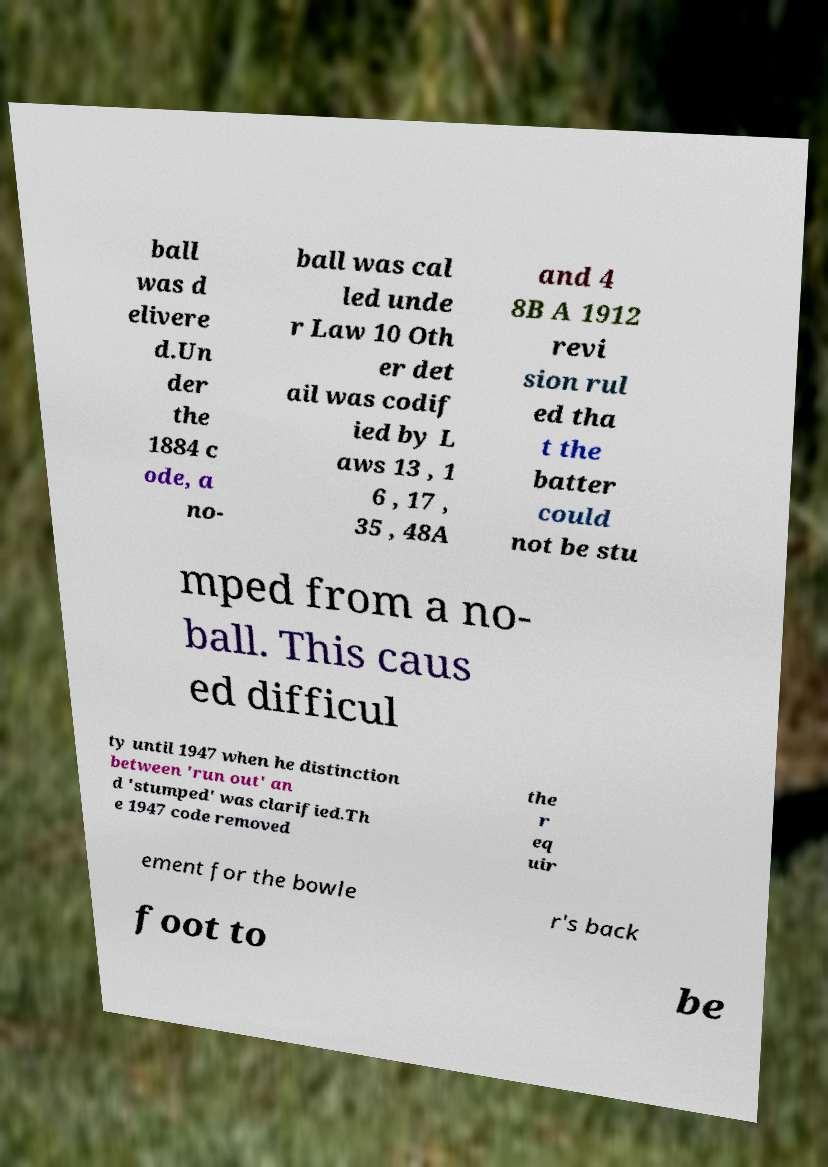For documentation purposes, I need the text within this image transcribed. Could you provide that? ball was d elivere d.Un der the 1884 c ode, a no- ball was cal led unde r Law 10 Oth er det ail was codif ied by L aws 13 , 1 6 , 17 , 35 , 48A and 4 8B A 1912 revi sion rul ed tha t the batter could not be stu mped from a no- ball. This caus ed difficul ty until 1947 when he distinction between 'run out' an d 'stumped' was clarified.Th e 1947 code removed the r eq uir ement for the bowle r's back foot to be 